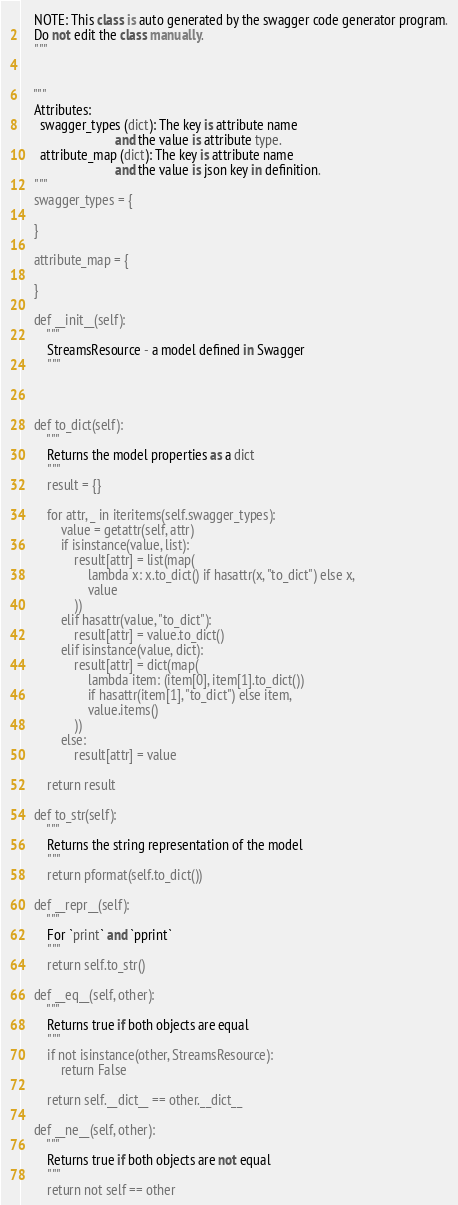Convert code to text. <code><loc_0><loc_0><loc_500><loc_500><_Python_>    NOTE: This class is auto generated by the swagger code generator program.
    Do not edit the class manually.
    """


    """
    Attributes:
      swagger_types (dict): The key is attribute name
                            and the value is attribute type.
      attribute_map (dict): The key is attribute name
                            and the value is json key in definition.
    """
    swagger_types = {
        
    }

    attribute_map = {
        
    }

    def __init__(self):
        """
        StreamsResource - a model defined in Swagger
        """



    def to_dict(self):
        """
        Returns the model properties as a dict
        """
        result = {}

        for attr, _ in iteritems(self.swagger_types):
            value = getattr(self, attr)
            if isinstance(value, list):
                result[attr] = list(map(
                    lambda x: x.to_dict() if hasattr(x, "to_dict") else x,
                    value
                ))
            elif hasattr(value, "to_dict"):
                result[attr] = value.to_dict()
            elif isinstance(value, dict):
                result[attr] = dict(map(
                    lambda item: (item[0], item[1].to_dict())
                    if hasattr(item[1], "to_dict") else item,
                    value.items()
                ))
            else:
                result[attr] = value

        return result

    def to_str(self):
        """
        Returns the string representation of the model
        """
        return pformat(self.to_dict())

    def __repr__(self):
        """
        For `print` and `pprint`
        """
        return self.to_str()

    def __eq__(self, other):
        """
        Returns true if both objects are equal
        """
        if not isinstance(other, StreamsResource):
            return False

        return self.__dict__ == other.__dict__

    def __ne__(self, other):
        """
        Returns true if both objects are not equal
        """
        return not self == other
</code> 